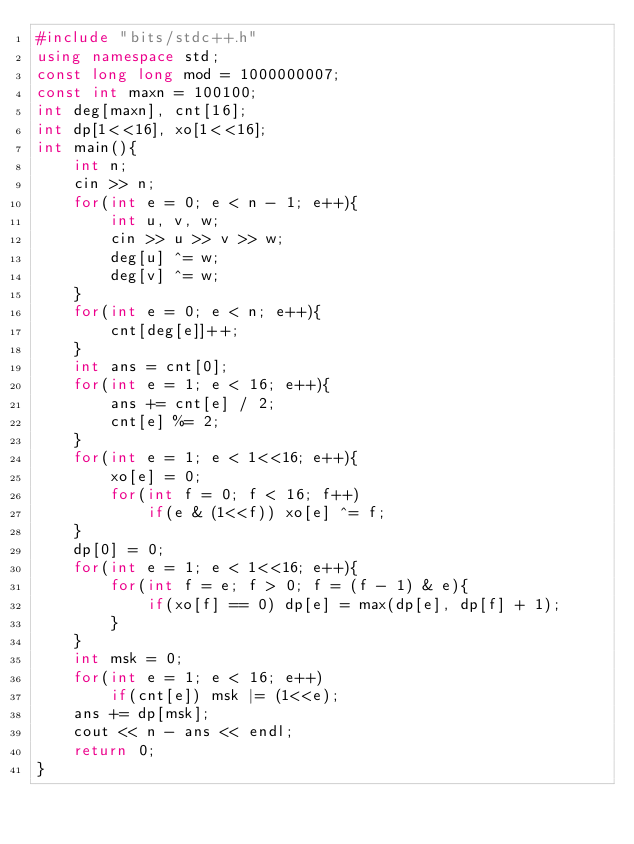<code> <loc_0><loc_0><loc_500><loc_500><_C++_>#include "bits/stdc++.h"
using namespace std;
const long long mod = 1000000007;
const int maxn = 100100;
int deg[maxn], cnt[16];
int dp[1<<16], xo[1<<16];
int main(){
    int n;
    cin >> n;
    for(int e = 0; e < n - 1; e++){
        int u, v, w;
        cin >> u >> v >> w;
        deg[u] ^= w;
        deg[v] ^= w;
    }
    for(int e = 0; e < n; e++){
        cnt[deg[e]]++;
    }
    int ans = cnt[0];
    for(int e = 1; e < 16; e++){
        ans += cnt[e] / 2;
        cnt[e] %= 2;
    }
    for(int e = 1; e < 1<<16; e++){
        xo[e] = 0;
        for(int f = 0; f < 16; f++)
            if(e & (1<<f)) xo[e] ^= f;
    }
    dp[0] = 0;
    for(int e = 1; e < 1<<16; e++){
        for(int f = e; f > 0; f = (f - 1) & e){
            if(xo[f] == 0) dp[e] = max(dp[e], dp[f] + 1);
        }
    }
    int msk = 0;
    for(int e = 1; e < 16; e++)
        if(cnt[e]) msk |= (1<<e);
    ans += dp[msk];
    cout << n - ans << endl;
	return 0;
}
</code> 